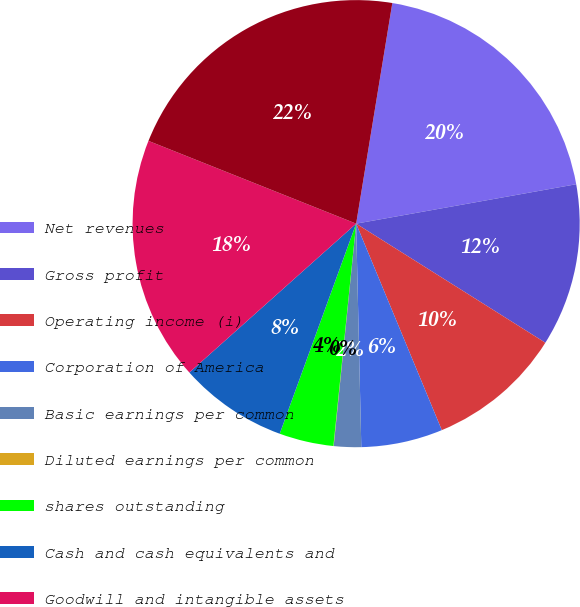Convert chart. <chart><loc_0><loc_0><loc_500><loc_500><pie_chart><fcel>Net revenues<fcel>Gross profit<fcel>Operating income (i)<fcel>Corporation of America<fcel>Basic earnings per common<fcel>Diluted earnings per common<fcel>shares outstanding<fcel>Cash and cash equivalents and<fcel>Goodwill and intangible assets<fcel>Total assets (f)<nl><fcel>19.59%<fcel>11.76%<fcel>9.8%<fcel>5.89%<fcel>1.97%<fcel>0.02%<fcel>3.93%<fcel>7.85%<fcel>17.63%<fcel>21.55%<nl></chart> 